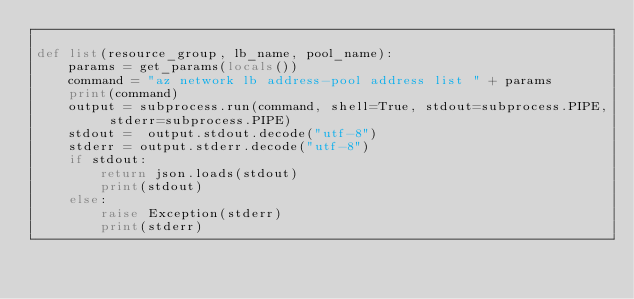<code> <loc_0><loc_0><loc_500><loc_500><_Python_>
def list(resource_group, lb_name, pool_name):
    params = get_params(locals())   
    command = "az network lb address-pool address list " + params
    print(command)
    output = subprocess.run(command, shell=True, stdout=subprocess.PIPE, stderr=subprocess.PIPE)
    stdout =  output.stdout.decode("utf-8")
    stderr = output.stderr.decode("utf-8")
    if stdout:
        return json.loads(stdout)
        print(stdout)
    else:
        raise Exception(stderr)
        print(stderr)  
</code> 